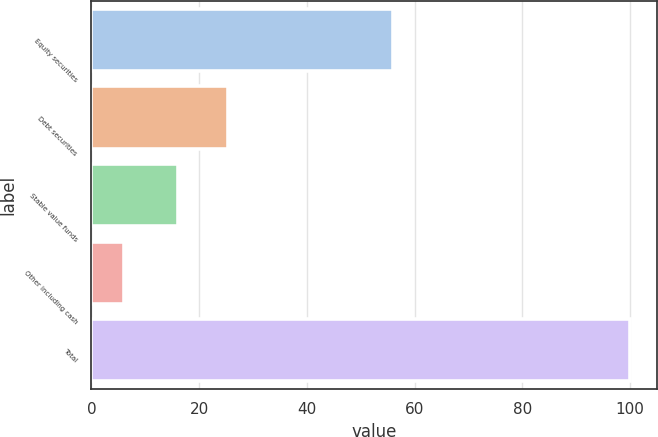Convert chart. <chart><loc_0><loc_0><loc_500><loc_500><bar_chart><fcel>Equity securities<fcel>Debt securities<fcel>Stable value funds<fcel>Other including cash<fcel>Total<nl><fcel>56<fcel>25.4<fcel>16<fcel>6<fcel>100<nl></chart> 